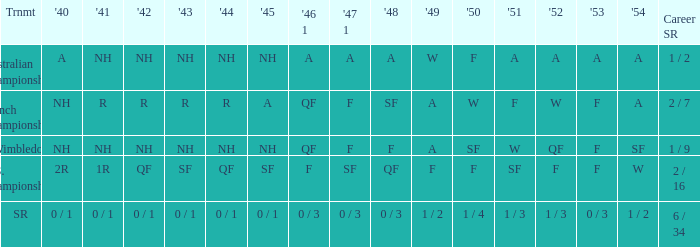What is the tournament that had a result of A in 1954 and NH in 1942? Australian Championships. 